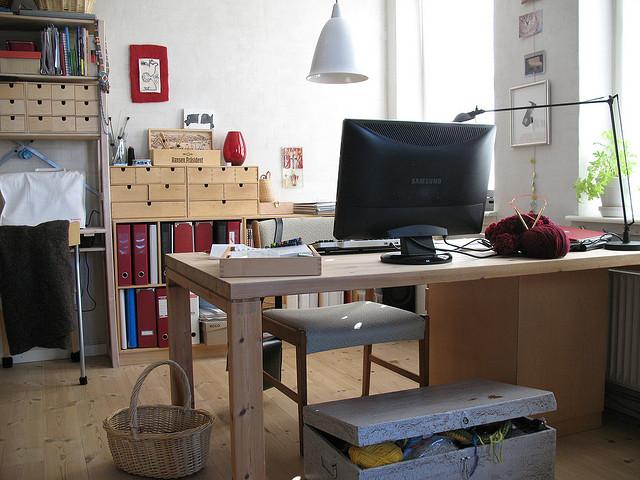What is the basket on the floor made out of?
Short answer required. Wicker. Is the desk lamp turned on?
Write a very short answer. No. What is sitting on the floor to the left of the desk?
Quick response, please. Basket. What are the metal bins under the far counters for?
Answer briefly. Storage. What kind of office is this?
Answer briefly. Home office. What kind of computer is this?
Give a very brief answer. Samsung. Is there a phone on the desk?
Answer briefly. No. 